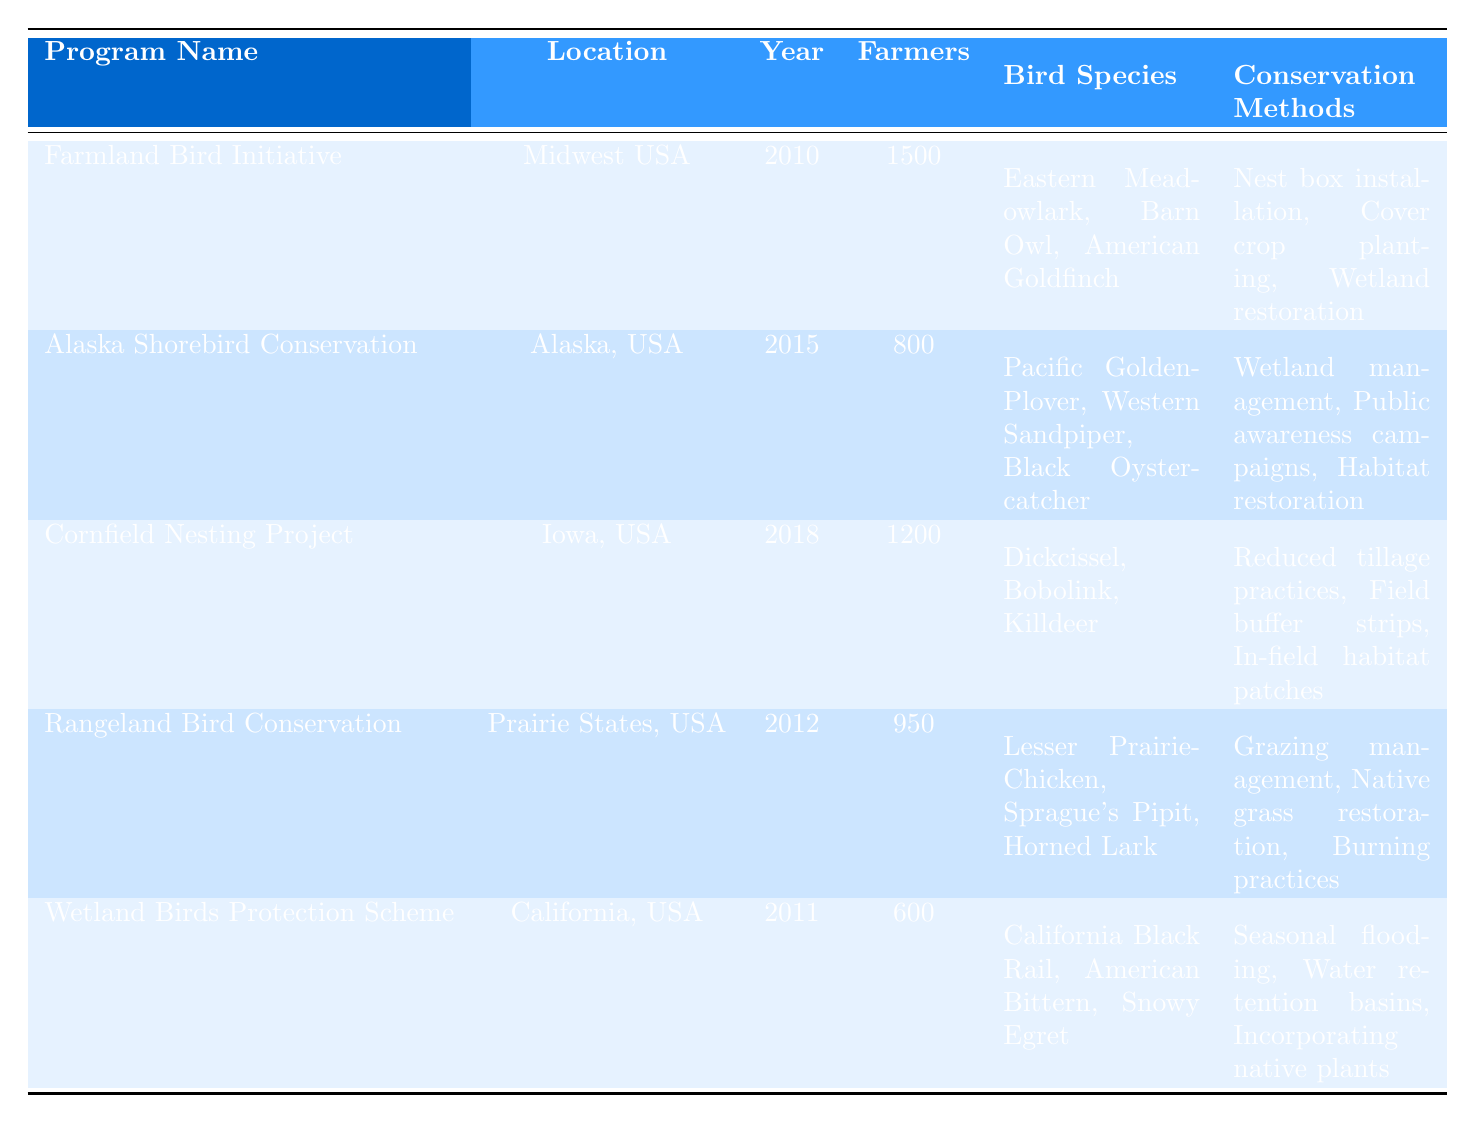What is the name of the program established in 2018? From the table, we can look at the "Year" column and find that the program established in 2018 is the "Cornfield Nesting Project."
Answer: Cornfield Nesting Project How many farmers are engaged in the Farmland Bird Initiative? The table lists the "Farmers Engaged" column for the "Farmland Bird Initiative," which shows that 1500 farmers are involved in this program.
Answer: 1500 Which program supports the Pacific Golden-Plover? By checking the "Bird Species Supported" column, we find that the "Alaska Shorebird Conservation" program lists the Pacific Golden-Plover as one of its supported species.
Answer: Alaska Shorebird Conservation What is the total number of farmers engaged across all programs? To find the total number of farmers engaged, we sum the "Farmers Engaged" values: 1500 + 800 + 1200 + 950 + 600 = 4050.
Answer: 4050 Which conservation method is used in the Wetland Birds Protection Scheme? The "Conservation Methods" column indicates that the Wetland Birds Protection Scheme utilizes seasonal flooding, water retention basins, and incorporating native plants.
Answer: Seasonal flooding, water retention basins, incorporating native plants Is the Rangeland Bird Conservation program older than the Alaska Shorebird Conservation program? The Rangeland Bird Conservation program was established in 2012, and the Alaska Shorebird Conservation was established in 2015. Since 2012 is earlier than 2015, the Rangeland program is indeed older.
Answer: Yes How many bird species are supported by the Cornfield Nesting Project? The "Bird Species Supported" column for the Cornfield Nesting Project lists three species: Dickcissel, Bobolink, and Killdeer. There are three bird species in total.
Answer: 3 Which location has the least number of farmers engaged? By comparing the "Farmers Engaged" column, we see that the Wetland Birds Protection Scheme has the least number of farmers engaged at 600.
Answer: California, USA What is the average number of farmers engaged in the conservation programs? We sum the farmers engaged: 1500 + 800 + 1200 + 950 + 600 = 4050. There are 5 programs, so the average is 4050/5 = 810.
Answer: 810 Are bird species supported in the Farmland Bird Initiative also seen in the Rangeland Bird Conservation program? The Farmland Bird Initiative supports Eastern Meadowlark, Barn Owl, and American Goldfinch, while the Rangeland program supports Lesser Prairie-Chicken, Sprague's Pipit, and Horned Lark. None of these species are the same.
Answer: No 